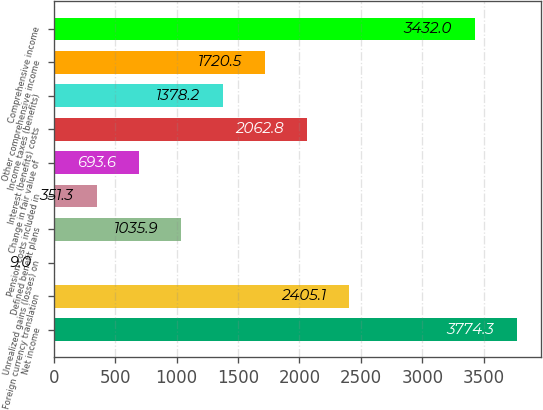Convert chart to OTSL. <chart><loc_0><loc_0><loc_500><loc_500><bar_chart><fcel>Net income<fcel>Foreign currency translation<fcel>Unrealized gains (losses) on<fcel>Defined benefit plans<fcel>Pension costs included in<fcel>Change in fair value of<fcel>Interest (benefits) costs<fcel>Income taxes (benefits)<fcel>Other comprehensive income<fcel>Comprehensive income<nl><fcel>3774.3<fcel>2405.1<fcel>9<fcel>1035.9<fcel>351.3<fcel>693.6<fcel>2062.8<fcel>1378.2<fcel>1720.5<fcel>3432<nl></chart> 